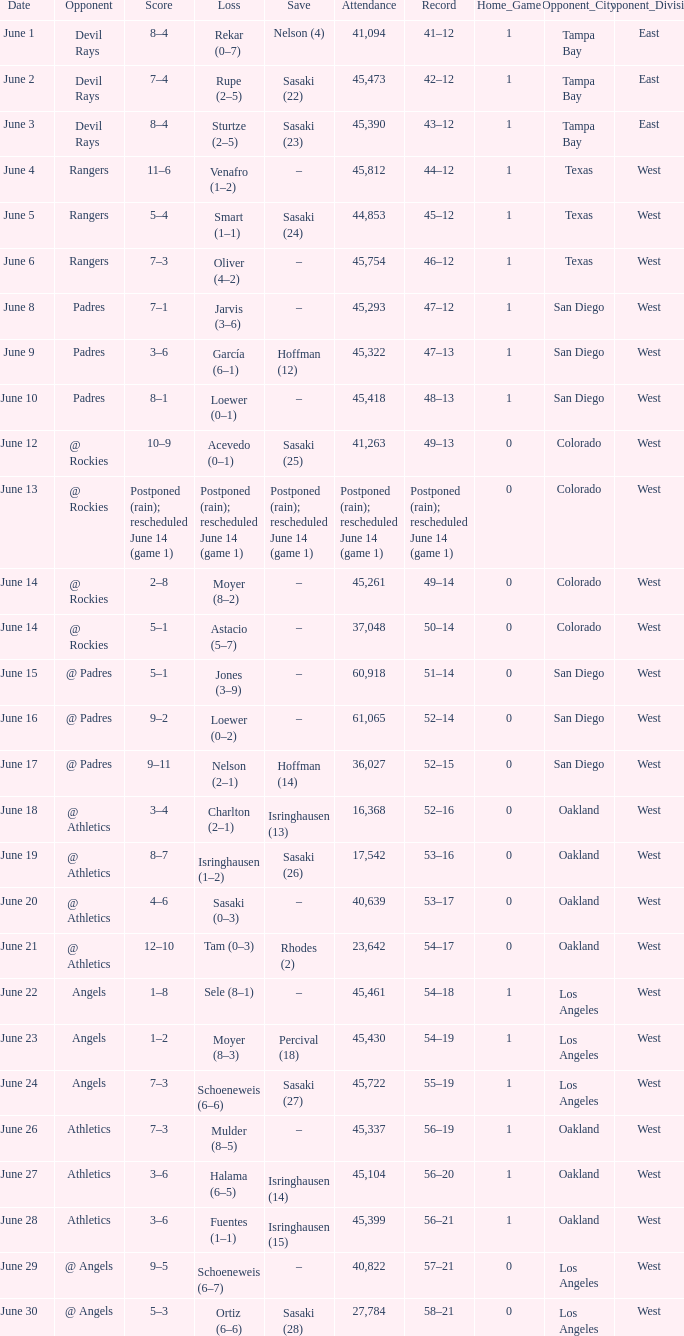What was the outcome of the mariners game when they held a record of 56–21? 3–6. Can you give me this table as a dict? {'header': ['Date', 'Opponent', 'Score', 'Loss', 'Save', 'Attendance', 'Record', 'Home_Game', 'Opponent_City', 'Opponent_Division'], 'rows': [['June 1', 'Devil Rays', '8–4', 'Rekar (0–7)', 'Nelson (4)', '41,094', '41–12', '1', 'Tampa Bay', 'East'], ['June 2', 'Devil Rays', '7–4', 'Rupe (2–5)', 'Sasaki (22)', '45,473', '42–12', '1', 'Tampa Bay', 'East'], ['June 3', 'Devil Rays', '8–4', 'Sturtze (2–5)', 'Sasaki (23)', '45,390', '43–12', '1', 'Tampa Bay', 'East'], ['June 4', 'Rangers', '11–6', 'Venafro (1–2)', '–', '45,812', '44–12', '1', 'Texas', 'West'], ['June 5', 'Rangers', '5–4', 'Smart (1–1)', 'Sasaki (24)', '44,853', '45–12', '1', 'Texas', 'West'], ['June 6', 'Rangers', '7–3', 'Oliver (4–2)', '–', '45,754', '46–12', '1', 'Texas', 'West'], ['June 8', 'Padres', '7–1', 'Jarvis (3–6)', '–', '45,293', '47–12', '1', 'San Diego', 'West'], ['June 9', 'Padres', '3–6', 'García (6–1)', 'Hoffman (12)', '45,322', '47–13', '1', 'San Diego', 'West'], ['June 10', 'Padres', '8–1', 'Loewer (0–1)', '–', '45,418', '48–13', '1', 'San Diego', 'West'], ['June 12', '@ Rockies', '10–9', 'Acevedo (0–1)', 'Sasaki (25)', '41,263', '49–13', '0', 'Colorado', 'West'], ['June 13', '@ Rockies', 'Postponed (rain); rescheduled June 14 (game 1)', 'Postponed (rain); rescheduled June 14 (game 1)', 'Postponed (rain); rescheduled June 14 (game 1)', 'Postponed (rain); rescheduled June 14 (game 1)', 'Postponed (rain); rescheduled June 14 (game 1)', '0', 'Colorado', 'West'], ['June 14', '@ Rockies', '2–8', 'Moyer (8–2)', '–', '45,261', '49–14', '0', 'Colorado', 'West'], ['June 14', '@ Rockies', '5–1', 'Astacio (5–7)', '–', '37,048', '50–14', '0', 'Colorado', 'West'], ['June 15', '@ Padres', '5–1', 'Jones (3–9)', '–', '60,918', '51–14', '0', 'San Diego', 'West'], ['June 16', '@ Padres', '9–2', 'Loewer (0–2)', '–', '61,065', '52–14', '0', 'San Diego', 'West'], ['June 17', '@ Padres', '9–11', 'Nelson (2–1)', 'Hoffman (14)', '36,027', '52–15', '0', 'San Diego', 'West'], ['June 18', '@ Athletics', '3–4', 'Charlton (2–1)', 'Isringhausen (13)', '16,368', '52–16', '0', 'Oakland', 'West'], ['June 19', '@ Athletics', '8–7', 'Isringhausen (1–2)', 'Sasaki (26)', '17,542', '53–16', '0', 'Oakland', 'West'], ['June 20', '@ Athletics', '4–6', 'Sasaki (0–3)', '–', '40,639', '53–17', '0', 'Oakland', 'West'], ['June 21', '@ Athletics', '12–10', 'Tam (0–3)', 'Rhodes (2)', '23,642', '54–17', '0', 'Oakland', 'West'], ['June 22', 'Angels', '1–8', 'Sele (8–1)', '–', '45,461', '54–18', '1', 'Los Angeles', 'West'], ['June 23', 'Angels', '1–2', 'Moyer (8–3)', 'Percival (18)', '45,430', '54–19', '1', 'Los Angeles', 'West'], ['June 24', 'Angels', '7–3', 'Schoeneweis (6–6)', 'Sasaki (27)', '45,722', '55–19', '1', 'Los Angeles', 'West'], ['June 26', 'Athletics', '7–3', 'Mulder (8–5)', '–', '45,337', '56–19', '1', 'Oakland', 'West'], ['June 27', 'Athletics', '3–6', 'Halama (6–5)', 'Isringhausen (14)', '45,104', '56–20', '1', 'Oakland', 'West'], ['June 28', 'Athletics', '3–6', 'Fuentes (1–1)', 'Isringhausen (15)', '45,399', '56–21', '1', 'Oakland', 'West'], ['June 29', '@ Angels', '9–5', 'Schoeneweis (6–7)', '–', '40,822', '57–21', '0', 'Los Angeles', 'West'], ['June 30', '@ Angels', '5–3', 'Ortiz (6–6)', 'Sasaki (28)', '27,784', '58–21', '0', 'Los Angeles', 'West']]} 